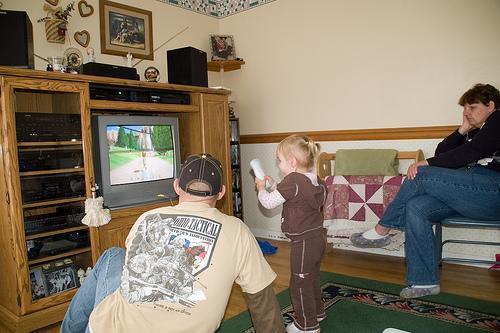How many people are there?
Give a very brief answer. 3. 